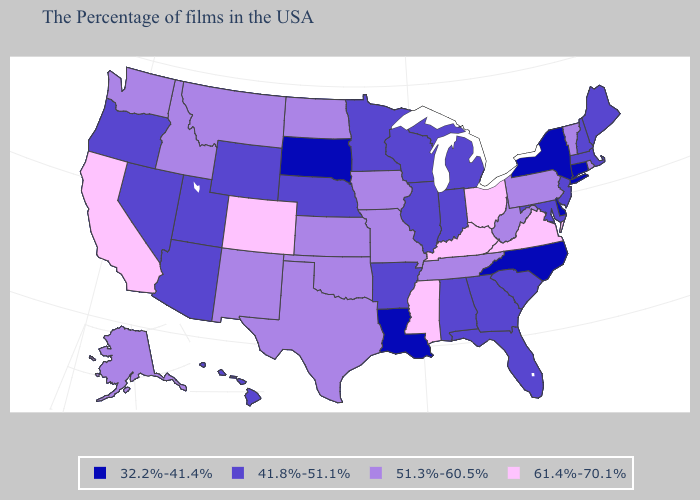Among the states that border Rhode Island , which have the highest value?
Keep it brief. Massachusetts. Name the states that have a value in the range 51.3%-60.5%?
Keep it brief. Rhode Island, Vermont, Pennsylvania, West Virginia, Tennessee, Missouri, Iowa, Kansas, Oklahoma, Texas, North Dakota, New Mexico, Montana, Idaho, Washington, Alaska. What is the value of Connecticut?
Write a very short answer. 32.2%-41.4%. Which states have the highest value in the USA?
Answer briefly. Virginia, Ohio, Kentucky, Mississippi, Colorado, California. Does Kentucky have the highest value in the USA?
Keep it brief. Yes. Which states hav the highest value in the West?
Keep it brief. Colorado, California. Among the states that border North Dakota , which have the highest value?
Answer briefly. Montana. Among the states that border North Dakota , which have the highest value?
Quick response, please. Montana. What is the value of Oklahoma?
Be succinct. 51.3%-60.5%. How many symbols are there in the legend?
Give a very brief answer. 4. What is the value of Nebraska?
Give a very brief answer. 41.8%-51.1%. Does West Virginia have the lowest value in the South?
Be succinct. No. What is the lowest value in the Northeast?
Concise answer only. 32.2%-41.4%. Is the legend a continuous bar?
Short answer required. No. Name the states that have a value in the range 41.8%-51.1%?
Quick response, please. Maine, Massachusetts, New Hampshire, New Jersey, Maryland, South Carolina, Florida, Georgia, Michigan, Indiana, Alabama, Wisconsin, Illinois, Arkansas, Minnesota, Nebraska, Wyoming, Utah, Arizona, Nevada, Oregon, Hawaii. 